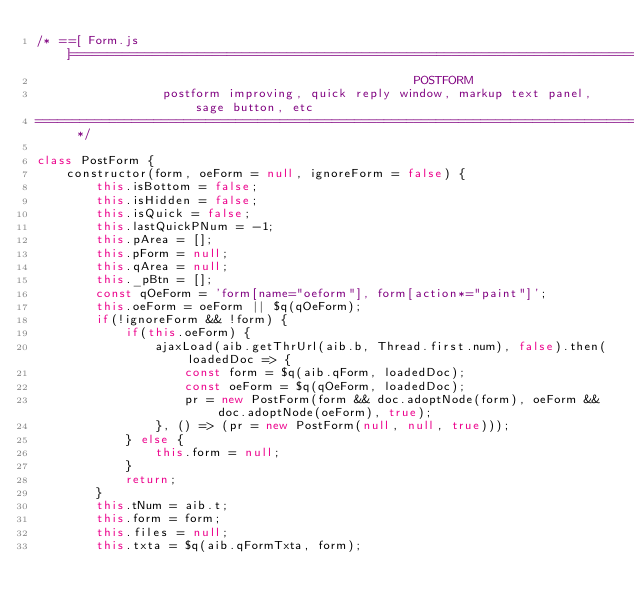Convert code to text. <code><loc_0><loc_0><loc_500><loc_500><_JavaScript_>/* ==[ Form.js ]==============================================================================================
                                                   POSTFORM
                 postform improving, quick reply window, markup text panel, sage button, etc
=========================================================================================================== */

class PostForm {
	constructor(form, oeForm = null, ignoreForm = false) {
		this.isBottom = false;
		this.isHidden = false;
		this.isQuick = false;
		this.lastQuickPNum = -1;
		this.pArea = [];
		this.pForm = null;
		this.qArea = null;
		this._pBtn = [];
		const qOeForm = 'form[name="oeform"], form[action*="paint"]';
		this.oeForm = oeForm || $q(qOeForm);
		if(!ignoreForm && !form) {
			if(this.oeForm) {
				ajaxLoad(aib.getThrUrl(aib.b, Thread.first.num), false).then(loadedDoc => {
					const form = $q(aib.qForm, loadedDoc);
					const oeForm = $q(qOeForm, loadedDoc);
					pr = new PostForm(form && doc.adoptNode(form), oeForm && doc.adoptNode(oeForm), true);
				}, () => (pr = new PostForm(null, null, true)));
			} else {
				this.form = null;
			}
			return;
		}
		this.tNum = aib.t;
		this.form = form;
		this.files = null;
		this.txta = $q(aib.qFormTxta, form);</code> 